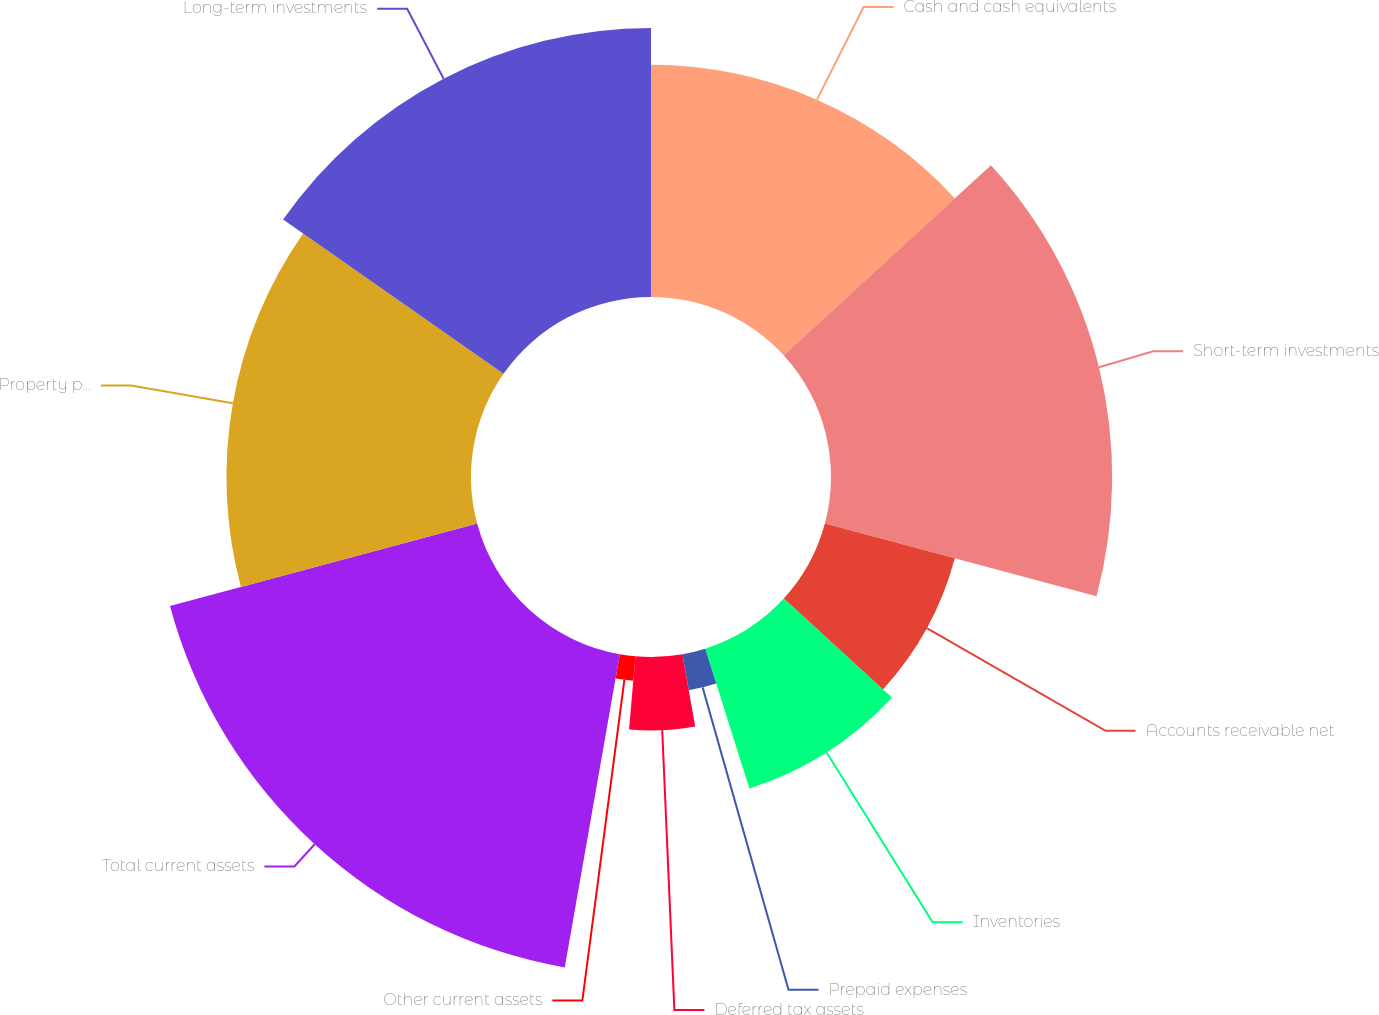<chart> <loc_0><loc_0><loc_500><loc_500><pie_chart><fcel>Cash and cash equivalents<fcel>Short-term investments<fcel>Accounts receivable net<fcel>Inventories<fcel>Prepaid expenses<fcel>Deferred tax assets<fcel>Other current assets<fcel>Total current assets<fcel>Property plant and equipment<fcel>Long-term investments<nl><fcel>13.19%<fcel>15.97%<fcel>7.64%<fcel>8.33%<fcel>2.08%<fcel>4.17%<fcel>1.39%<fcel>18.06%<fcel>13.89%<fcel>15.28%<nl></chart> 